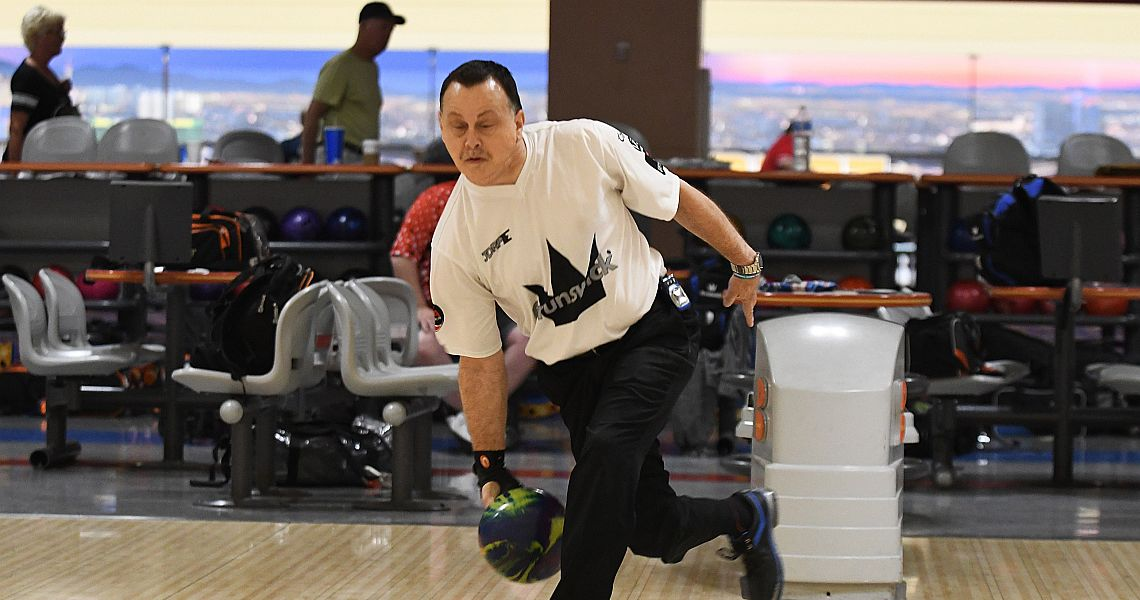What can be concluded about the social dynamics among the participants based on the visible interactions and atmosphere? The image suggests a friendly yet competitive social dynamic among the participants. The presence of team uniforms and personalized equipment indicates that the bowlers likely know each other well and are part of a recognized group, such as a league or club. The relaxed posture of the other individuals in the background hints at a camaraderie and enjoyment, highlighting that while the event is competitive, it is also a social occasion where participants bond over their shared interest in bowling. 